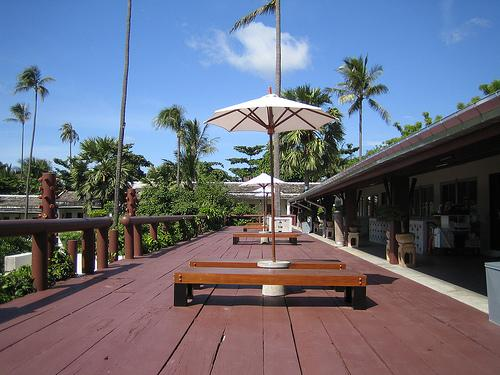Write a brief description of the main objects in the image and their apparent purpose. The main objects are the white open umbrellas to provide shade over the wooden benches beneath them, designed for people to sit and relax in this peaceful setting. In one sentence, describe the general atmosphere of the image. The image portrays a serene and sunny atmosphere with white umbrellas, brown benches, and palm trees on a wooden walkway. What are the key components of this scene, and how would you describe their arrangement? The key components are white open umbrellas, brown wooden benches, a walkway, white clouds, blue sky, and tall palm trees; they are arranged primarily along the walkway and scattered in the sky. Identify the dominant colors in the scene and describe their effect on the overall image. The dominant colors are white, blue, and brown, resulting in a harmonious and peaceful scene. What is the overall mood of the image, and what visual elements contribute to it? The overall mood of the image is calm and inviting, with visual elements such as the white open umbrellas, blue sky with white clouds, and wooden benches on a walkway contributing to this ambiance. Describe the setting and the primary structure in the image. The setting is an outdoor area with a wooden walkway, and the primary structure consists of white open umbrellas covering brown wooden benches. Provide a brief description of the main elements in the image. There are white open umbrellas, brown wooden benches on a walkway, white clouds in the blue sky, a wood walkway, tall palm trees, and a white umbrella with a brown post. Using descriptive words, create a vivid image of the scene in the reader's mind. Under the azure sky adorned with fluffy white clouds, elegant white umbrellas cast soothing shadows over inviting brown wooden benches, surrounded by the lush greenery of tall palm trees along the picturesque walkway. Write a short sentence describing the central focal point of the image. The central focal point is the white open umbrellas shading the wooden benches along the walkway. Mention the main objects in the image and their colors. The main objects are white open umbrellas, brown wooden benches, a blue sky with white clouds, and green palm trees. 